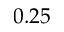<formula> <loc_0><loc_0><loc_500><loc_500>0 . 2 5</formula> 